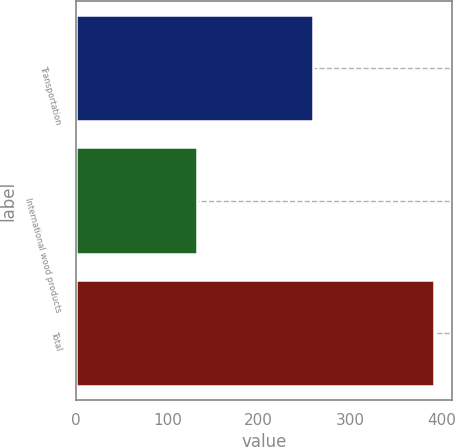<chart> <loc_0><loc_0><loc_500><loc_500><bar_chart><fcel>Transportation<fcel>International wood products<fcel>Total<nl><fcel>259<fcel>133<fcel>392<nl></chart> 